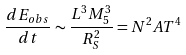<formula> <loc_0><loc_0><loc_500><loc_500>\frac { d E _ { o b s } } { d t } \sim \frac { L ^ { 3 } M _ { 5 } ^ { 3 } } { R _ { S } ^ { 2 } } = N ^ { 2 } A T ^ { 4 }</formula> 